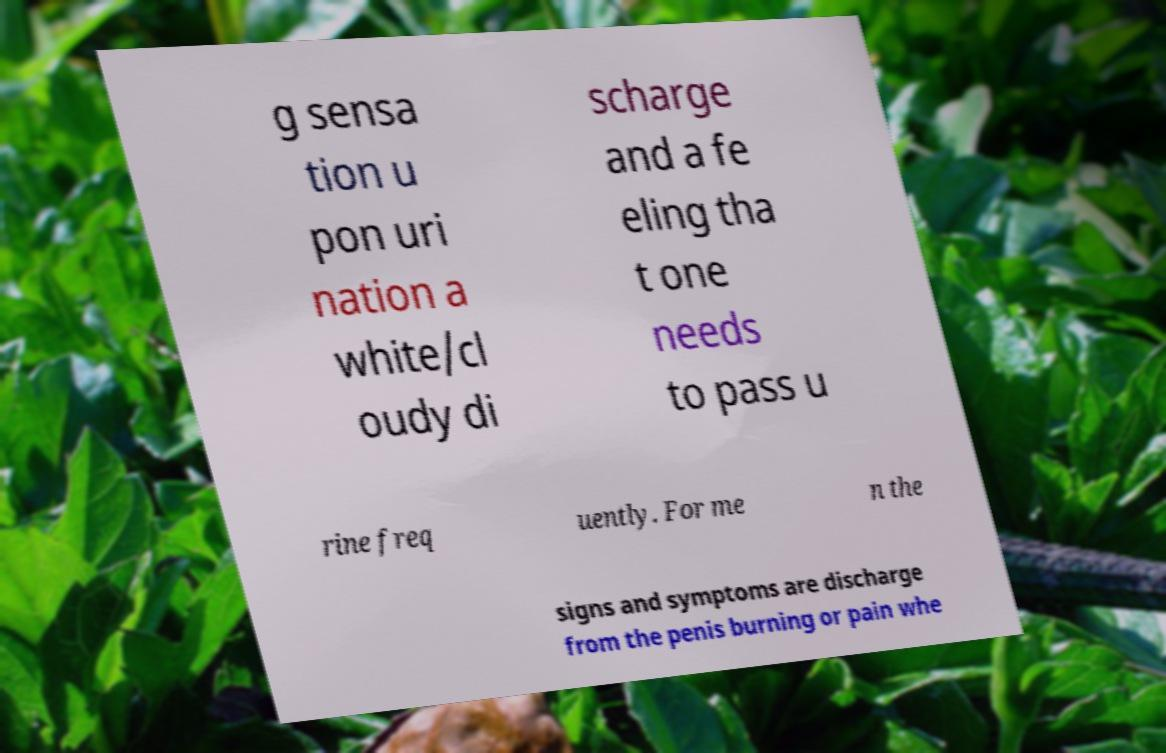Please read and relay the text visible in this image. What does it say? g sensa tion u pon uri nation a white/cl oudy di scharge and a fe eling tha t one needs to pass u rine freq uently. For me n the signs and symptoms are discharge from the penis burning or pain whe 